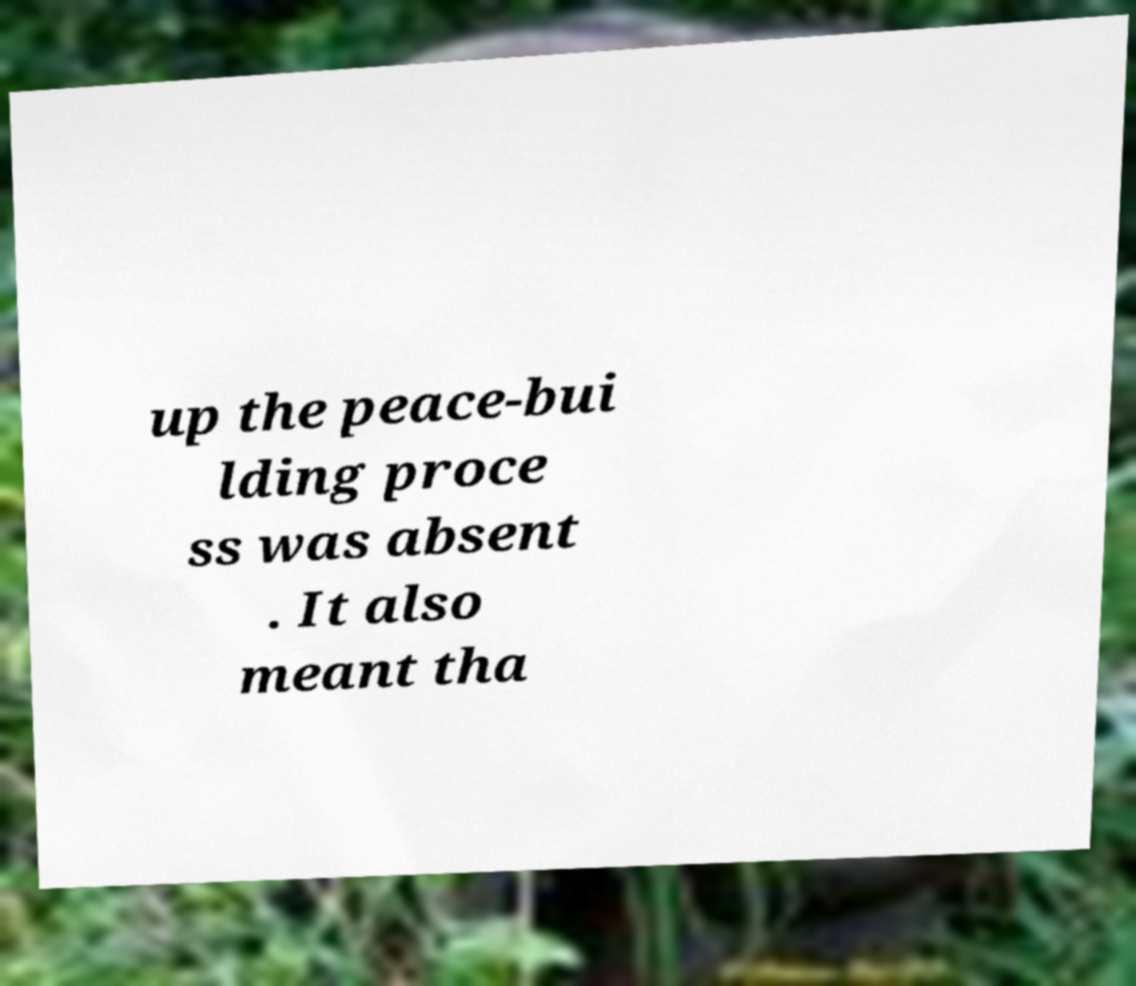What messages or text are displayed in this image? I need them in a readable, typed format. up the peace-bui lding proce ss was absent . It also meant tha 